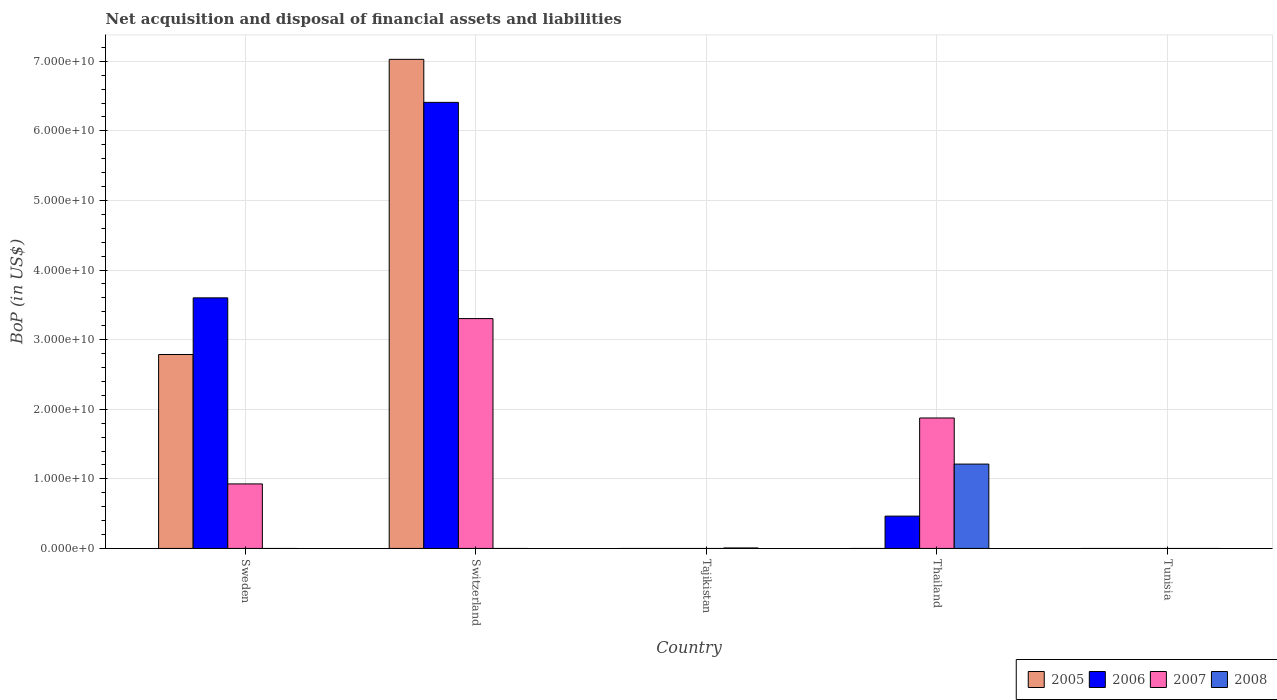How many different coloured bars are there?
Your answer should be compact. 4. Are the number of bars on each tick of the X-axis equal?
Your answer should be very brief. No. How many bars are there on the 3rd tick from the left?
Your answer should be very brief. 1. What is the label of the 4th group of bars from the left?
Your answer should be very brief. Thailand. What is the Balance of Payments in 2006 in Sweden?
Your answer should be compact. 3.60e+1. Across all countries, what is the maximum Balance of Payments in 2008?
Your response must be concise. 1.21e+1. In which country was the Balance of Payments in 2006 maximum?
Your answer should be very brief. Switzerland. What is the total Balance of Payments in 2006 in the graph?
Make the answer very short. 1.05e+11. What is the difference between the Balance of Payments in 2007 in Sweden and that in Thailand?
Provide a succinct answer. -9.48e+09. What is the average Balance of Payments in 2006 per country?
Offer a terse response. 2.09e+1. What is the difference between the Balance of Payments of/in 2006 and Balance of Payments of/in 2007 in Switzerland?
Make the answer very short. 3.11e+1. What is the ratio of the Balance of Payments in 2007 in Sweden to that in Thailand?
Provide a succinct answer. 0.49. What is the difference between the highest and the second highest Balance of Payments in 2006?
Your answer should be compact. 2.81e+1. What is the difference between the highest and the lowest Balance of Payments in 2005?
Make the answer very short. 7.03e+1. In how many countries, is the Balance of Payments in 2006 greater than the average Balance of Payments in 2006 taken over all countries?
Offer a terse response. 2. Is it the case that in every country, the sum of the Balance of Payments in 2007 and Balance of Payments in 2006 is greater than the sum of Balance of Payments in 2008 and Balance of Payments in 2005?
Give a very brief answer. No. How many bars are there?
Give a very brief answer. 10. Are all the bars in the graph horizontal?
Keep it short and to the point. No. How many countries are there in the graph?
Provide a succinct answer. 5. Does the graph contain any zero values?
Your answer should be compact. Yes. Where does the legend appear in the graph?
Keep it short and to the point. Bottom right. How are the legend labels stacked?
Your answer should be very brief. Horizontal. What is the title of the graph?
Provide a short and direct response. Net acquisition and disposal of financial assets and liabilities. What is the label or title of the Y-axis?
Make the answer very short. BoP (in US$). What is the BoP (in US$) in 2005 in Sweden?
Provide a succinct answer. 2.79e+1. What is the BoP (in US$) of 2006 in Sweden?
Ensure brevity in your answer.  3.60e+1. What is the BoP (in US$) of 2007 in Sweden?
Your answer should be compact. 9.27e+09. What is the BoP (in US$) in 2008 in Sweden?
Give a very brief answer. 0. What is the BoP (in US$) in 2005 in Switzerland?
Offer a very short reply. 7.03e+1. What is the BoP (in US$) of 2006 in Switzerland?
Offer a terse response. 6.41e+1. What is the BoP (in US$) in 2007 in Switzerland?
Keep it short and to the point. 3.30e+1. What is the BoP (in US$) of 2008 in Switzerland?
Keep it short and to the point. 0. What is the BoP (in US$) in 2007 in Tajikistan?
Make the answer very short. 0. What is the BoP (in US$) in 2008 in Tajikistan?
Your answer should be very brief. 6.87e+07. What is the BoP (in US$) of 2006 in Thailand?
Your answer should be very brief. 4.64e+09. What is the BoP (in US$) in 2007 in Thailand?
Ensure brevity in your answer.  1.87e+1. What is the BoP (in US$) in 2008 in Thailand?
Your answer should be compact. 1.21e+1. What is the BoP (in US$) in 2007 in Tunisia?
Your response must be concise. 0. Across all countries, what is the maximum BoP (in US$) of 2005?
Ensure brevity in your answer.  7.03e+1. Across all countries, what is the maximum BoP (in US$) of 2006?
Provide a short and direct response. 6.41e+1. Across all countries, what is the maximum BoP (in US$) of 2007?
Your response must be concise. 3.30e+1. Across all countries, what is the maximum BoP (in US$) in 2008?
Offer a very short reply. 1.21e+1. Across all countries, what is the minimum BoP (in US$) in 2006?
Your answer should be compact. 0. Across all countries, what is the minimum BoP (in US$) of 2007?
Provide a short and direct response. 0. What is the total BoP (in US$) of 2005 in the graph?
Your answer should be very brief. 9.81e+1. What is the total BoP (in US$) of 2006 in the graph?
Provide a succinct answer. 1.05e+11. What is the total BoP (in US$) in 2007 in the graph?
Offer a terse response. 6.10e+1. What is the total BoP (in US$) of 2008 in the graph?
Your answer should be very brief. 1.22e+1. What is the difference between the BoP (in US$) in 2005 in Sweden and that in Switzerland?
Your answer should be compact. -4.24e+1. What is the difference between the BoP (in US$) of 2006 in Sweden and that in Switzerland?
Ensure brevity in your answer.  -2.81e+1. What is the difference between the BoP (in US$) in 2007 in Sweden and that in Switzerland?
Your response must be concise. -2.38e+1. What is the difference between the BoP (in US$) in 2006 in Sweden and that in Thailand?
Keep it short and to the point. 3.14e+1. What is the difference between the BoP (in US$) in 2007 in Sweden and that in Thailand?
Your answer should be very brief. -9.48e+09. What is the difference between the BoP (in US$) in 2006 in Switzerland and that in Thailand?
Your answer should be very brief. 5.95e+1. What is the difference between the BoP (in US$) in 2007 in Switzerland and that in Thailand?
Make the answer very short. 1.43e+1. What is the difference between the BoP (in US$) of 2008 in Tajikistan and that in Thailand?
Provide a short and direct response. -1.21e+1. What is the difference between the BoP (in US$) in 2005 in Sweden and the BoP (in US$) in 2006 in Switzerland?
Keep it short and to the point. -3.62e+1. What is the difference between the BoP (in US$) of 2005 in Sweden and the BoP (in US$) of 2007 in Switzerland?
Provide a succinct answer. -5.16e+09. What is the difference between the BoP (in US$) of 2006 in Sweden and the BoP (in US$) of 2007 in Switzerland?
Keep it short and to the point. 2.98e+09. What is the difference between the BoP (in US$) of 2005 in Sweden and the BoP (in US$) of 2008 in Tajikistan?
Your answer should be compact. 2.78e+1. What is the difference between the BoP (in US$) of 2006 in Sweden and the BoP (in US$) of 2008 in Tajikistan?
Provide a short and direct response. 3.59e+1. What is the difference between the BoP (in US$) of 2007 in Sweden and the BoP (in US$) of 2008 in Tajikistan?
Offer a very short reply. 9.20e+09. What is the difference between the BoP (in US$) of 2005 in Sweden and the BoP (in US$) of 2006 in Thailand?
Give a very brief answer. 2.32e+1. What is the difference between the BoP (in US$) of 2005 in Sweden and the BoP (in US$) of 2007 in Thailand?
Make the answer very short. 9.12e+09. What is the difference between the BoP (in US$) in 2005 in Sweden and the BoP (in US$) in 2008 in Thailand?
Make the answer very short. 1.57e+1. What is the difference between the BoP (in US$) in 2006 in Sweden and the BoP (in US$) in 2007 in Thailand?
Make the answer very short. 1.73e+1. What is the difference between the BoP (in US$) of 2006 in Sweden and the BoP (in US$) of 2008 in Thailand?
Offer a very short reply. 2.39e+1. What is the difference between the BoP (in US$) of 2007 in Sweden and the BoP (in US$) of 2008 in Thailand?
Your answer should be compact. -2.85e+09. What is the difference between the BoP (in US$) in 2005 in Switzerland and the BoP (in US$) in 2008 in Tajikistan?
Offer a terse response. 7.02e+1. What is the difference between the BoP (in US$) of 2006 in Switzerland and the BoP (in US$) of 2008 in Tajikistan?
Make the answer very short. 6.40e+1. What is the difference between the BoP (in US$) in 2007 in Switzerland and the BoP (in US$) in 2008 in Tajikistan?
Provide a short and direct response. 3.30e+1. What is the difference between the BoP (in US$) of 2005 in Switzerland and the BoP (in US$) of 2006 in Thailand?
Give a very brief answer. 6.56e+1. What is the difference between the BoP (in US$) in 2005 in Switzerland and the BoP (in US$) in 2007 in Thailand?
Make the answer very short. 5.15e+1. What is the difference between the BoP (in US$) of 2005 in Switzerland and the BoP (in US$) of 2008 in Thailand?
Keep it short and to the point. 5.82e+1. What is the difference between the BoP (in US$) of 2006 in Switzerland and the BoP (in US$) of 2007 in Thailand?
Keep it short and to the point. 4.53e+1. What is the difference between the BoP (in US$) in 2006 in Switzerland and the BoP (in US$) in 2008 in Thailand?
Your answer should be very brief. 5.20e+1. What is the difference between the BoP (in US$) of 2007 in Switzerland and the BoP (in US$) of 2008 in Thailand?
Provide a succinct answer. 2.09e+1. What is the average BoP (in US$) in 2005 per country?
Keep it short and to the point. 1.96e+1. What is the average BoP (in US$) of 2006 per country?
Provide a succinct answer. 2.09e+1. What is the average BoP (in US$) of 2007 per country?
Keep it short and to the point. 1.22e+1. What is the average BoP (in US$) in 2008 per country?
Provide a succinct answer. 2.44e+09. What is the difference between the BoP (in US$) of 2005 and BoP (in US$) of 2006 in Sweden?
Provide a short and direct response. -8.14e+09. What is the difference between the BoP (in US$) in 2005 and BoP (in US$) in 2007 in Sweden?
Make the answer very short. 1.86e+1. What is the difference between the BoP (in US$) of 2006 and BoP (in US$) of 2007 in Sweden?
Ensure brevity in your answer.  2.67e+1. What is the difference between the BoP (in US$) of 2005 and BoP (in US$) of 2006 in Switzerland?
Provide a short and direct response. 6.18e+09. What is the difference between the BoP (in US$) in 2005 and BoP (in US$) in 2007 in Switzerland?
Ensure brevity in your answer.  3.73e+1. What is the difference between the BoP (in US$) of 2006 and BoP (in US$) of 2007 in Switzerland?
Provide a succinct answer. 3.11e+1. What is the difference between the BoP (in US$) in 2006 and BoP (in US$) in 2007 in Thailand?
Your answer should be compact. -1.41e+1. What is the difference between the BoP (in US$) of 2006 and BoP (in US$) of 2008 in Thailand?
Offer a very short reply. -7.48e+09. What is the difference between the BoP (in US$) in 2007 and BoP (in US$) in 2008 in Thailand?
Offer a very short reply. 6.63e+09. What is the ratio of the BoP (in US$) of 2005 in Sweden to that in Switzerland?
Provide a succinct answer. 0.4. What is the ratio of the BoP (in US$) of 2006 in Sweden to that in Switzerland?
Your response must be concise. 0.56. What is the ratio of the BoP (in US$) in 2007 in Sweden to that in Switzerland?
Provide a succinct answer. 0.28. What is the ratio of the BoP (in US$) in 2006 in Sweden to that in Thailand?
Ensure brevity in your answer.  7.75. What is the ratio of the BoP (in US$) of 2007 in Sweden to that in Thailand?
Your answer should be very brief. 0.49. What is the ratio of the BoP (in US$) in 2006 in Switzerland to that in Thailand?
Your answer should be compact. 13.8. What is the ratio of the BoP (in US$) of 2007 in Switzerland to that in Thailand?
Ensure brevity in your answer.  1.76. What is the ratio of the BoP (in US$) of 2008 in Tajikistan to that in Thailand?
Give a very brief answer. 0.01. What is the difference between the highest and the second highest BoP (in US$) of 2006?
Offer a very short reply. 2.81e+1. What is the difference between the highest and the second highest BoP (in US$) in 2007?
Offer a terse response. 1.43e+1. What is the difference between the highest and the lowest BoP (in US$) in 2005?
Offer a terse response. 7.03e+1. What is the difference between the highest and the lowest BoP (in US$) in 2006?
Your answer should be very brief. 6.41e+1. What is the difference between the highest and the lowest BoP (in US$) of 2007?
Provide a succinct answer. 3.30e+1. What is the difference between the highest and the lowest BoP (in US$) of 2008?
Your answer should be compact. 1.21e+1. 